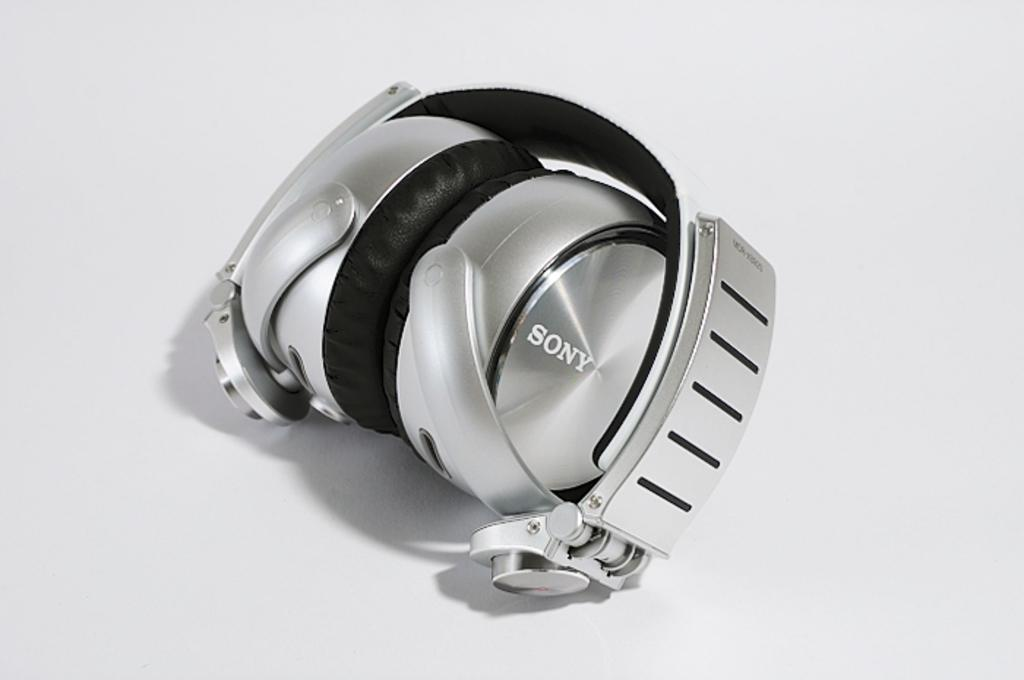<image>
Provide a brief description of the given image. A silver pair of new headphones by Sony 